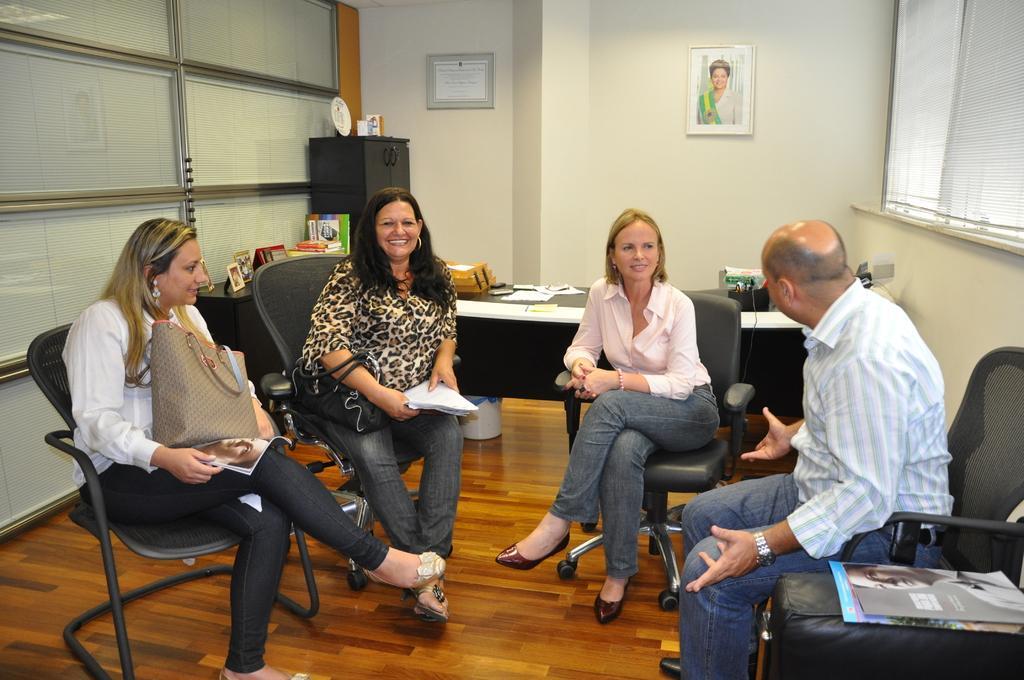How would you summarize this image in a sentence or two? This image is taken inside a room. There are four people in this room, three women and a man. They are sitting on the chairs. In the bottom of the image there is a floor. In the background there is a wall with paintings and picture frames on it with a window and window blind. At the back there is a table with many things on it. In the left side of the image woman is sitting on the chair and holding a hand bag. In the right side of the image a man is sitting on the chair and there are two magazines on the stool. 